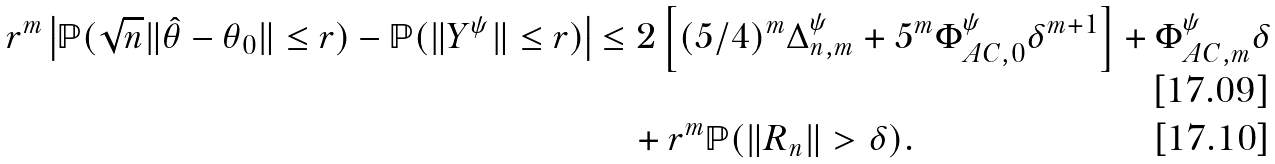<formula> <loc_0><loc_0><loc_500><loc_500>r ^ { m } \left | \mathbb { P } ( \sqrt { n } \| \hat { \theta } - \theta _ { 0 } \| \leq r ) - \mathbb { P } ( \| Y ^ { \psi } \| \leq r ) \right | & \leq 2 \left [ ( 5 / 4 ) ^ { m } \Delta _ { n , m } ^ { \psi } + 5 ^ { m } \Phi _ { A C , 0 } ^ { \psi } \delta ^ { m + 1 } \right ] + \Phi _ { A C , m } ^ { \psi } \delta \\ & \quad + r ^ { m } \mathbb { P } ( \| R _ { n } \| > \delta ) .</formula> 